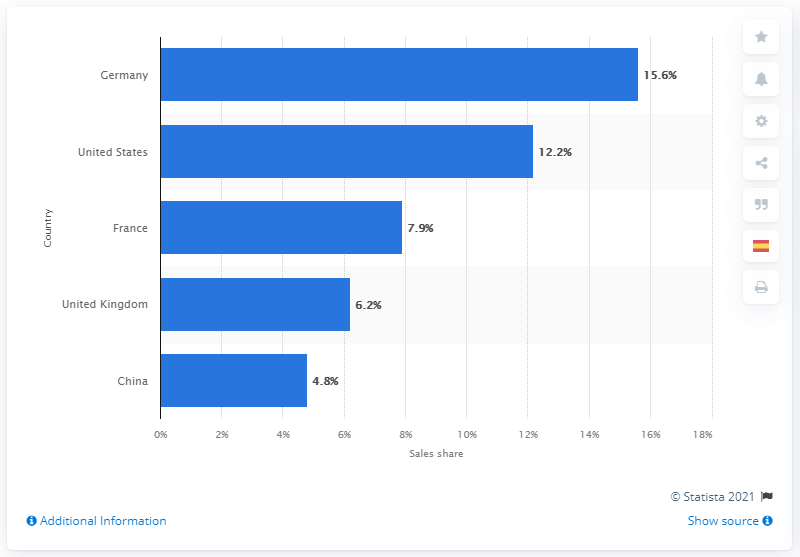Give some essential details in this illustration. IKEA's leading selling country in 2020 was Germany. In 2020, IKEA's total sales in Germany accounted for 15.6% of the company's overall sales worldwide. 